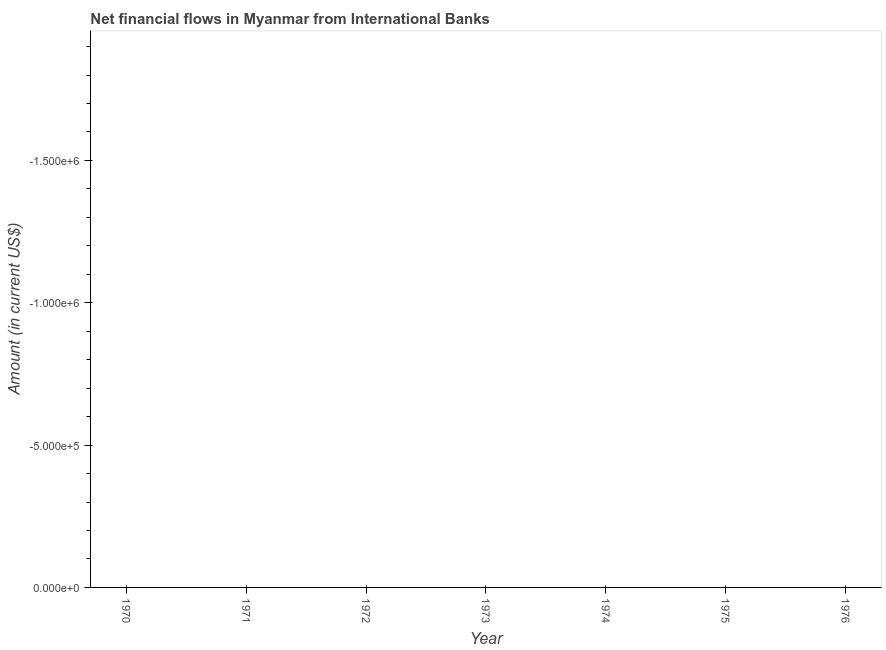In how many years, is the net financial flows from ibrd greater than the average net financial flows from ibrd taken over all years?
Give a very brief answer. 0. Does the graph contain grids?
Provide a short and direct response. No. What is the title of the graph?
Your answer should be very brief. Net financial flows in Myanmar from International Banks. What is the label or title of the X-axis?
Provide a succinct answer. Year. What is the Amount (in current US$) of 1971?
Provide a short and direct response. 0. What is the Amount (in current US$) in 1972?
Ensure brevity in your answer.  0. What is the Amount (in current US$) of 1973?
Your response must be concise. 0. What is the Amount (in current US$) of 1975?
Ensure brevity in your answer.  0. What is the Amount (in current US$) of 1976?
Offer a very short reply. 0. 